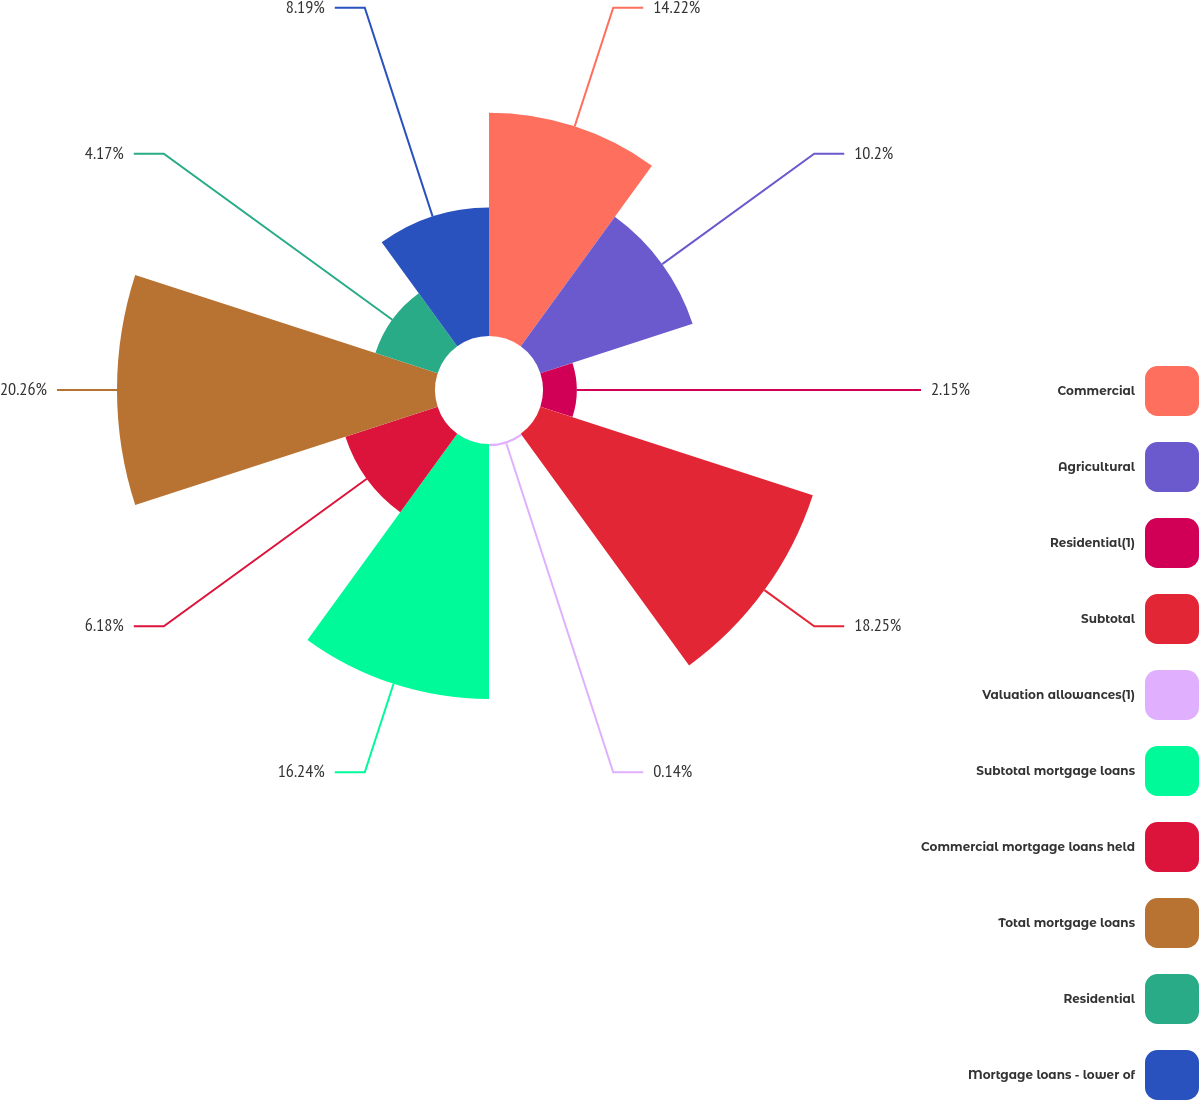<chart> <loc_0><loc_0><loc_500><loc_500><pie_chart><fcel>Commercial<fcel>Agricultural<fcel>Residential(1)<fcel>Subtotal<fcel>Valuation allowances(1)<fcel>Subtotal mortgage loans<fcel>Commercial mortgage loans held<fcel>Total mortgage loans<fcel>Residential<fcel>Mortgage loans - lower of<nl><fcel>14.22%<fcel>10.2%<fcel>2.15%<fcel>18.25%<fcel>0.14%<fcel>16.24%<fcel>6.18%<fcel>20.26%<fcel>4.17%<fcel>8.19%<nl></chart> 